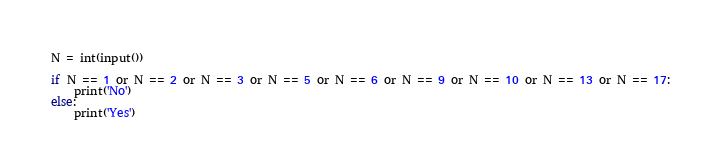<code> <loc_0><loc_0><loc_500><loc_500><_Python_>N = int(input())

if N == 1 or N == 2 or N == 3 or N == 5 or N == 6 or N == 9 or N == 10 or N == 13 or N == 17:
    print('No')
else:
    print('Yes')
</code> 